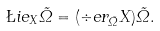Convert formula to latex. <formula><loc_0><loc_0><loc_500><loc_500>\L i e _ { X } \tilde { \Omega } = ( \div e r _ { \tilde { \Omega } } X ) \tilde { \Omega } .</formula> 